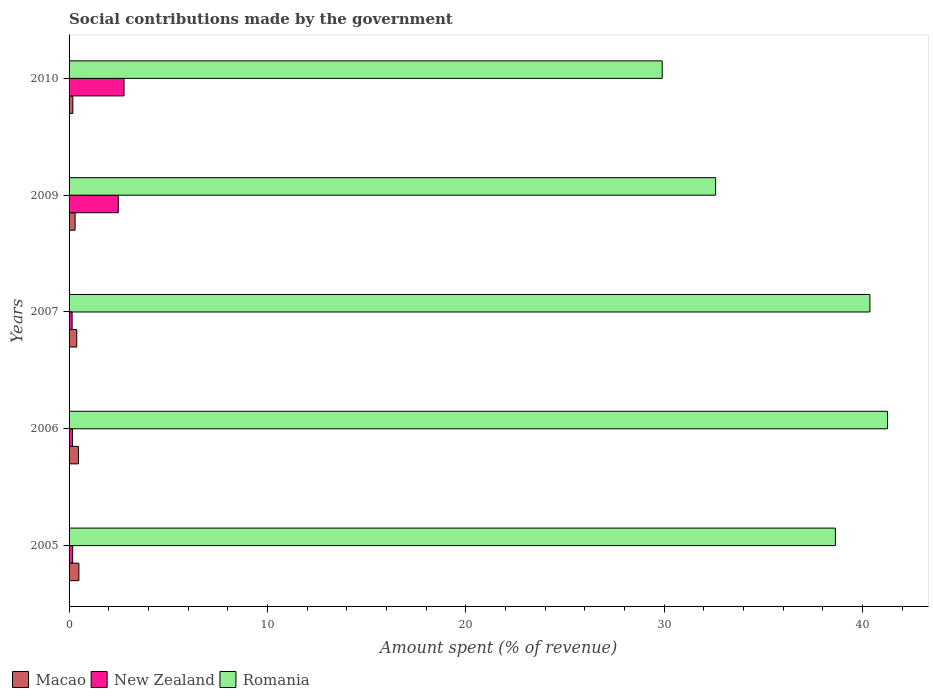Are the number of bars per tick equal to the number of legend labels?
Give a very brief answer. Yes. How many bars are there on the 5th tick from the top?
Your response must be concise. 3. How many bars are there on the 4th tick from the bottom?
Your answer should be compact. 3. In how many cases, is the number of bars for a given year not equal to the number of legend labels?
Offer a very short reply. 0. What is the amount spent (in %) on social contributions in New Zealand in 2007?
Provide a succinct answer. 0.15. Across all years, what is the maximum amount spent (in %) on social contributions in New Zealand?
Give a very brief answer. 2.77. Across all years, what is the minimum amount spent (in %) on social contributions in New Zealand?
Provide a short and direct response. 0.15. In which year was the amount spent (in %) on social contributions in Macao maximum?
Provide a short and direct response. 2005. What is the total amount spent (in %) on social contributions in Romania in the graph?
Offer a very short reply. 182.77. What is the difference between the amount spent (in %) on social contributions in Macao in 2006 and that in 2009?
Your answer should be compact. 0.17. What is the difference between the amount spent (in %) on social contributions in Romania in 2006 and the amount spent (in %) on social contributions in Macao in 2010?
Provide a short and direct response. 41.07. What is the average amount spent (in %) on social contributions in Macao per year?
Give a very brief answer. 0.37. In the year 2007, what is the difference between the amount spent (in %) on social contributions in Romania and amount spent (in %) on social contributions in Macao?
Provide a succinct answer. 39.99. What is the ratio of the amount spent (in %) on social contributions in New Zealand in 2006 to that in 2007?
Your answer should be compact. 1.11. Is the amount spent (in %) on social contributions in Romania in 2006 less than that in 2009?
Provide a succinct answer. No. Is the difference between the amount spent (in %) on social contributions in Romania in 2005 and 2007 greater than the difference between the amount spent (in %) on social contributions in Macao in 2005 and 2007?
Provide a short and direct response. No. What is the difference between the highest and the second highest amount spent (in %) on social contributions in Macao?
Offer a very short reply. 0.02. What is the difference between the highest and the lowest amount spent (in %) on social contributions in New Zealand?
Offer a terse response. 2.62. In how many years, is the amount spent (in %) on social contributions in Romania greater than the average amount spent (in %) on social contributions in Romania taken over all years?
Offer a very short reply. 3. Is the sum of the amount spent (in %) on social contributions in New Zealand in 2006 and 2009 greater than the maximum amount spent (in %) on social contributions in Romania across all years?
Offer a very short reply. No. What does the 3rd bar from the top in 2009 represents?
Ensure brevity in your answer.  Macao. What does the 3rd bar from the bottom in 2010 represents?
Your answer should be very brief. Romania. How many years are there in the graph?
Keep it short and to the point. 5. What is the difference between two consecutive major ticks on the X-axis?
Offer a terse response. 10. Where does the legend appear in the graph?
Offer a very short reply. Bottom left. How many legend labels are there?
Offer a terse response. 3. What is the title of the graph?
Provide a succinct answer. Social contributions made by the government. Does "Iraq" appear as one of the legend labels in the graph?
Ensure brevity in your answer.  No. What is the label or title of the X-axis?
Provide a succinct answer. Amount spent (% of revenue). What is the Amount spent (% of revenue) of Macao in 2005?
Provide a succinct answer. 0.5. What is the Amount spent (% of revenue) in New Zealand in 2005?
Make the answer very short. 0.18. What is the Amount spent (% of revenue) in Romania in 2005?
Your response must be concise. 38.63. What is the Amount spent (% of revenue) in Macao in 2006?
Provide a succinct answer. 0.47. What is the Amount spent (% of revenue) of New Zealand in 2006?
Ensure brevity in your answer.  0.17. What is the Amount spent (% of revenue) of Romania in 2006?
Make the answer very short. 41.27. What is the Amount spent (% of revenue) of Macao in 2007?
Provide a succinct answer. 0.39. What is the Amount spent (% of revenue) of New Zealand in 2007?
Your answer should be compact. 0.15. What is the Amount spent (% of revenue) of Romania in 2007?
Make the answer very short. 40.37. What is the Amount spent (% of revenue) of Macao in 2009?
Your answer should be compact. 0.3. What is the Amount spent (% of revenue) of New Zealand in 2009?
Provide a succinct answer. 2.48. What is the Amount spent (% of revenue) in Romania in 2009?
Your answer should be very brief. 32.6. What is the Amount spent (% of revenue) in Macao in 2010?
Provide a short and direct response. 0.19. What is the Amount spent (% of revenue) in New Zealand in 2010?
Your answer should be very brief. 2.77. What is the Amount spent (% of revenue) in Romania in 2010?
Keep it short and to the point. 29.9. Across all years, what is the maximum Amount spent (% of revenue) in Macao?
Keep it short and to the point. 0.5. Across all years, what is the maximum Amount spent (% of revenue) of New Zealand?
Provide a short and direct response. 2.77. Across all years, what is the maximum Amount spent (% of revenue) in Romania?
Give a very brief answer. 41.27. Across all years, what is the minimum Amount spent (% of revenue) of Macao?
Provide a succinct answer. 0.19. Across all years, what is the minimum Amount spent (% of revenue) of New Zealand?
Provide a short and direct response. 0.15. Across all years, what is the minimum Amount spent (% of revenue) of Romania?
Provide a short and direct response. 29.9. What is the total Amount spent (% of revenue) of Macao in the graph?
Provide a succinct answer. 1.85. What is the total Amount spent (% of revenue) in New Zealand in the graph?
Ensure brevity in your answer.  5.76. What is the total Amount spent (% of revenue) of Romania in the graph?
Offer a terse response. 182.77. What is the difference between the Amount spent (% of revenue) in Macao in 2005 and that in 2006?
Your response must be concise. 0.02. What is the difference between the Amount spent (% of revenue) of New Zealand in 2005 and that in 2006?
Offer a terse response. 0.01. What is the difference between the Amount spent (% of revenue) in Romania in 2005 and that in 2006?
Your response must be concise. -2.63. What is the difference between the Amount spent (% of revenue) of Macao in 2005 and that in 2007?
Keep it short and to the point. 0.11. What is the difference between the Amount spent (% of revenue) in New Zealand in 2005 and that in 2007?
Keep it short and to the point. 0.03. What is the difference between the Amount spent (% of revenue) of Romania in 2005 and that in 2007?
Provide a short and direct response. -1.74. What is the difference between the Amount spent (% of revenue) of Macao in 2005 and that in 2009?
Give a very brief answer. 0.19. What is the difference between the Amount spent (% of revenue) in New Zealand in 2005 and that in 2009?
Ensure brevity in your answer.  -2.3. What is the difference between the Amount spent (% of revenue) in Romania in 2005 and that in 2009?
Make the answer very short. 6.04. What is the difference between the Amount spent (% of revenue) of Macao in 2005 and that in 2010?
Offer a terse response. 0.31. What is the difference between the Amount spent (% of revenue) in New Zealand in 2005 and that in 2010?
Offer a very short reply. -2.59. What is the difference between the Amount spent (% of revenue) in Romania in 2005 and that in 2010?
Your answer should be very brief. 8.73. What is the difference between the Amount spent (% of revenue) of Macao in 2006 and that in 2007?
Ensure brevity in your answer.  0.08. What is the difference between the Amount spent (% of revenue) in New Zealand in 2006 and that in 2007?
Your response must be concise. 0.02. What is the difference between the Amount spent (% of revenue) of Romania in 2006 and that in 2007?
Provide a short and direct response. 0.89. What is the difference between the Amount spent (% of revenue) in Macao in 2006 and that in 2009?
Your answer should be compact. 0.17. What is the difference between the Amount spent (% of revenue) of New Zealand in 2006 and that in 2009?
Ensure brevity in your answer.  -2.31. What is the difference between the Amount spent (% of revenue) in Romania in 2006 and that in 2009?
Provide a short and direct response. 8.67. What is the difference between the Amount spent (% of revenue) in Macao in 2006 and that in 2010?
Offer a terse response. 0.28. What is the difference between the Amount spent (% of revenue) of New Zealand in 2006 and that in 2010?
Give a very brief answer. -2.6. What is the difference between the Amount spent (% of revenue) of Romania in 2006 and that in 2010?
Keep it short and to the point. 11.36. What is the difference between the Amount spent (% of revenue) in Macao in 2007 and that in 2009?
Your answer should be very brief. 0.08. What is the difference between the Amount spent (% of revenue) in New Zealand in 2007 and that in 2009?
Give a very brief answer. -2.33. What is the difference between the Amount spent (% of revenue) in Romania in 2007 and that in 2009?
Your response must be concise. 7.78. What is the difference between the Amount spent (% of revenue) of Macao in 2007 and that in 2010?
Provide a short and direct response. 0.2. What is the difference between the Amount spent (% of revenue) of New Zealand in 2007 and that in 2010?
Provide a succinct answer. -2.62. What is the difference between the Amount spent (% of revenue) of Romania in 2007 and that in 2010?
Provide a succinct answer. 10.47. What is the difference between the Amount spent (% of revenue) in Macao in 2009 and that in 2010?
Offer a very short reply. 0.11. What is the difference between the Amount spent (% of revenue) in New Zealand in 2009 and that in 2010?
Provide a succinct answer. -0.29. What is the difference between the Amount spent (% of revenue) of Romania in 2009 and that in 2010?
Give a very brief answer. 2.69. What is the difference between the Amount spent (% of revenue) in Macao in 2005 and the Amount spent (% of revenue) in New Zealand in 2006?
Ensure brevity in your answer.  0.32. What is the difference between the Amount spent (% of revenue) of Macao in 2005 and the Amount spent (% of revenue) of Romania in 2006?
Your answer should be very brief. -40.77. What is the difference between the Amount spent (% of revenue) in New Zealand in 2005 and the Amount spent (% of revenue) in Romania in 2006?
Provide a succinct answer. -41.08. What is the difference between the Amount spent (% of revenue) of Macao in 2005 and the Amount spent (% of revenue) of New Zealand in 2007?
Give a very brief answer. 0.34. What is the difference between the Amount spent (% of revenue) of Macao in 2005 and the Amount spent (% of revenue) of Romania in 2007?
Your answer should be compact. -39.88. What is the difference between the Amount spent (% of revenue) in New Zealand in 2005 and the Amount spent (% of revenue) in Romania in 2007?
Provide a short and direct response. -40.19. What is the difference between the Amount spent (% of revenue) in Macao in 2005 and the Amount spent (% of revenue) in New Zealand in 2009?
Your answer should be compact. -1.99. What is the difference between the Amount spent (% of revenue) of Macao in 2005 and the Amount spent (% of revenue) of Romania in 2009?
Your answer should be very brief. -32.1. What is the difference between the Amount spent (% of revenue) in New Zealand in 2005 and the Amount spent (% of revenue) in Romania in 2009?
Your answer should be very brief. -32.42. What is the difference between the Amount spent (% of revenue) in Macao in 2005 and the Amount spent (% of revenue) in New Zealand in 2010?
Keep it short and to the point. -2.28. What is the difference between the Amount spent (% of revenue) of Macao in 2005 and the Amount spent (% of revenue) of Romania in 2010?
Provide a short and direct response. -29.41. What is the difference between the Amount spent (% of revenue) of New Zealand in 2005 and the Amount spent (% of revenue) of Romania in 2010?
Keep it short and to the point. -29.72. What is the difference between the Amount spent (% of revenue) in Macao in 2006 and the Amount spent (% of revenue) in New Zealand in 2007?
Your answer should be very brief. 0.32. What is the difference between the Amount spent (% of revenue) of Macao in 2006 and the Amount spent (% of revenue) of Romania in 2007?
Your answer should be very brief. -39.9. What is the difference between the Amount spent (% of revenue) of New Zealand in 2006 and the Amount spent (% of revenue) of Romania in 2007?
Your answer should be compact. -40.2. What is the difference between the Amount spent (% of revenue) in Macao in 2006 and the Amount spent (% of revenue) in New Zealand in 2009?
Offer a very short reply. -2.01. What is the difference between the Amount spent (% of revenue) of Macao in 2006 and the Amount spent (% of revenue) of Romania in 2009?
Offer a terse response. -32.13. What is the difference between the Amount spent (% of revenue) in New Zealand in 2006 and the Amount spent (% of revenue) in Romania in 2009?
Your response must be concise. -32.43. What is the difference between the Amount spent (% of revenue) in Macao in 2006 and the Amount spent (% of revenue) in New Zealand in 2010?
Offer a very short reply. -2.3. What is the difference between the Amount spent (% of revenue) in Macao in 2006 and the Amount spent (% of revenue) in Romania in 2010?
Your response must be concise. -29.43. What is the difference between the Amount spent (% of revenue) of New Zealand in 2006 and the Amount spent (% of revenue) of Romania in 2010?
Keep it short and to the point. -29.73. What is the difference between the Amount spent (% of revenue) of Macao in 2007 and the Amount spent (% of revenue) of New Zealand in 2009?
Your response must be concise. -2.09. What is the difference between the Amount spent (% of revenue) in Macao in 2007 and the Amount spent (% of revenue) in Romania in 2009?
Give a very brief answer. -32.21. What is the difference between the Amount spent (% of revenue) of New Zealand in 2007 and the Amount spent (% of revenue) of Romania in 2009?
Keep it short and to the point. -32.44. What is the difference between the Amount spent (% of revenue) in Macao in 2007 and the Amount spent (% of revenue) in New Zealand in 2010?
Your response must be concise. -2.38. What is the difference between the Amount spent (% of revenue) of Macao in 2007 and the Amount spent (% of revenue) of Romania in 2010?
Your response must be concise. -29.52. What is the difference between the Amount spent (% of revenue) of New Zealand in 2007 and the Amount spent (% of revenue) of Romania in 2010?
Provide a succinct answer. -29.75. What is the difference between the Amount spent (% of revenue) of Macao in 2009 and the Amount spent (% of revenue) of New Zealand in 2010?
Give a very brief answer. -2.47. What is the difference between the Amount spent (% of revenue) of Macao in 2009 and the Amount spent (% of revenue) of Romania in 2010?
Your answer should be very brief. -29.6. What is the difference between the Amount spent (% of revenue) in New Zealand in 2009 and the Amount spent (% of revenue) in Romania in 2010?
Your answer should be compact. -27.42. What is the average Amount spent (% of revenue) in Macao per year?
Make the answer very short. 0.37. What is the average Amount spent (% of revenue) of New Zealand per year?
Give a very brief answer. 1.15. What is the average Amount spent (% of revenue) in Romania per year?
Provide a succinct answer. 36.55. In the year 2005, what is the difference between the Amount spent (% of revenue) of Macao and Amount spent (% of revenue) of New Zealand?
Ensure brevity in your answer.  0.31. In the year 2005, what is the difference between the Amount spent (% of revenue) in Macao and Amount spent (% of revenue) in Romania?
Provide a succinct answer. -38.14. In the year 2005, what is the difference between the Amount spent (% of revenue) in New Zealand and Amount spent (% of revenue) in Romania?
Provide a succinct answer. -38.45. In the year 2006, what is the difference between the Amount spent (% of revenue) in Macao and Amount spent (% of revenue) in New Zealand?
Keep it short and to the point. 0.3. In the year 2006, what is the difference between the Amount spent (% of revenue) in Macao and Amount spent (% of revenue) in Romania?
Your answer should be very brief. -40.79. In the year 2006, what is the difference between the Amount spent (% of revenue) in New Zealand and Amount spent (% of revenue) in Romania?
Provide a succinct answer. -41.09. In the year 2007, what is the difference between the Amount spent (% of revenue) of Macao and Amount spent (% of revenue) of New Zealand?
Make the answer very short. 0.23. In the year 2007, what is the difference between the Amount spent (% of revenue) of Macao and Amount spent (% of revenue) of Romania?
Your response must be concise. -39.99. In the year 2007, what is the difference between the Amount spent (% of revenue) in New Zealand and Amount spent (% of revenue) in Romania?
Your answer should be compact. -40.22. In the year 2009, what is the difference between the Amount spent (% of revenue) in Macao and Amount spent (% of revenue) in New Zealand?
Your answer should be very brief. -2.18. In the year 2009, what is the difference between the Amount spent (% of revenue) of Macao and Amount spent (% of revenue) of Romania?
Give a very brief answer. -32.29. In the year 2009, what is the difference between the Amount spent (% of revenue) in New Zealand and Amount spent (% of revenue) in Romania?
Ensure brevity in your answer.  -30.11. In the year 2010, what is the difference between the Amount spent (% of revenue) in Macao and Amount spent (% of revenue) in New Zealand?
Make the answer very short. -2.58. In the year 2010, what is the difference between the Amount spent (% of revenue) in Macao and Amount spent (% of revenue) in Romania?
Your answer should be compact. -29.71. In the year 2010, what is the difference between the Amount spent (% of revenue) in New Zealand and Amount spent (% of revenue) in Romania?
Give a very brief answer. -27.13. What is the ratio of the Amount spent (% of revenue) in Macao in 2005 to that in 2006?
Provide a succinct answer. 1.05. What is the ratio of the Amount spent (% of revenue) of New Zealand in 2005 to that in 2006?
Ensure brevity in your answer.  1.06. What is the ratio of the Amount spent (% of revenue) in Romania in 2005 to that in 2006?
Provide a succinct answer. 0.94. What is the ratio of the Amount spent (% of revenue) of Macao in 2005 to that in 2007?
Offer a very short reply. 1.28. What is the ratio of the Amount spent (% of revenue) of New Zealand in 2005 to that in 2007?
Offer a very short reply. 1.18. What is the ratio of the Amount spent (% of revenue) of Romania in 2005 to that in 2007?
Your answer should be very brief. 0.96. What is the ratio of the Amount spent (% of revenue) in Macao in 2005 to that in 2009?
Your response must be concise. 1.63. What is the ratio of the Amount spent (% of revenue) in New Zealand in 2005 to that in 2009?
Make the answer very short. 0.07. What is the ratio of the Amount spent (% of revenue) of Romania in 2005 to that in 2009?
Ensure brevity in your answer.  1.19. What is the ratio of the Amount spent (% of revenue) of Macao in 2005 to that in 2010?
Ensure brevity in your answer.  2.6. What is the ratio of the Amount spent (% of revenue) in New Zealand in 2005 to that in 2010?
Your answer should be compact. 0.07. What is the ratio of the Amount spent (% of revenue) of Romania in 2005 to that in 2010?
Provide a succinct answer. 1.29. What is the ratio of the Amount spent (% of revenue) of Macao in 2006 to that in 2007?
Give a very brief answer. 1.22. What is the ratio of the Amount spent (% of revenue) of New Zealand in 2006 to that in 2007?
Ensure brevity in your answer.  1.11. What is the ratio of the Amount spent (% of revenue) of Romania in 2006 to that in 2007?
Provide a short and direct response. 1.02. What is the ratio of the Amount spent (% of revenue) in Macao in 2006 to that in 2009?
Keep it short and to the point. 1.55. What is the ratio of the Amount spent (% of revenue) of New Zealand in 2006 to that in 2009?
Keep it short and to the point. 0.07. What is the ratio of the Amount spent (% of revenue) of Romania in 2006 to that in 2009?
Offer a terse response. 1.27. What is the ratio of the Amount spent (% of revenue) in Macao in 2006 to that in 2010?
Give a very brief answer. 2.48. What is the ratio of the Amount spent (% of revenue) of New Zealand in 2006 to that in 2010?
Make the answer very short. 0.06. What is the ratio of the Amount spent (% of revenue) in Romania in 2006 to that in 2010?
Provide a short and direct response. 1.38. What is the ratio of the Amount spent (% of revenue) in Macao in 2007 to that in 2009?
Ensure brevity in your answer.  1.28. What is the ratio of the Amount spent (% of revenue) in New Zealand in 2007 to that in 2009?
Ensure brevity in your answer.  0.06. What is the ratio of the Amount spent (% of revenue) in Romania in 2007 to that in 2009?
Offer a terse response. 1.24. What is the ratio of the Amount spent (% of revenue) of Macao in 2007 to that in 2010?
Your answer should be very brief. 2.04. What is the ratio of the Amount spent (% of revenue) in New Zealand in 2007 to that in 2010?
Your answer should be very brief. 0.06. What is the ratio of the Amount spent (% of revenue) in Romania in 2007 to that in 2010?
Offer a terse response. 1.35. What is the ratio of the Amount spent (% of revenue) in Macao in 2009 to that in 2010?
Keep it short and to the point. 1.6. What is the ratio of the Amount spent (% of revenue) of New Zealand in 2009 to that in 2010?
Ensure brevity in your answer.  0.9. What is the ratio of the Amount spent (% of revenue) in Romania in 2009 to that in 2010?
Provide a succinct answer. 1.09. What is the difference between the highest and the second highest Amount spent (% of revenue) in Macao?
Keep it short and to the point. 0.02. What is the difference between the highest and the second highest Amount spent (% of revenue) of New Zealand?
Provide a short and direct response. 0.29. What is the difference between the highest and the second highest Amount spent (% of revenue) of Romania?
Keep it short and to the point. 0.89. What is the difference between the highest and the lowest Amount spent (% of revenue) in Macao?
Your answer should be very brief. 0.31. What is the difference between the highest and the lowest Amount spent (% of revenue) of New Zealand?
Provide a succinct answer. 2.62. What is the difference between the highest and the lowest Amount spent (% of revenue) of Romania?
Make the answer very short. 11.36. 